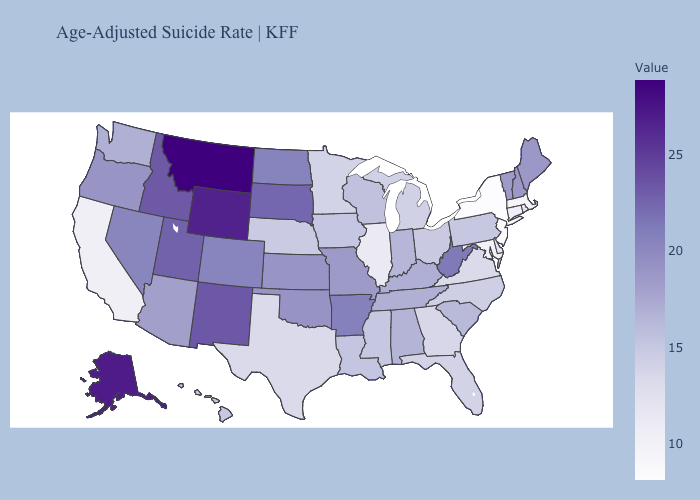Does Oregon have a higher value than New Jersey?
Short answer required. Yes. Which states have the highest value in the USA?
Answer briefly. Montana. Does Maine have the highest value in the Northeast?
Concise answer only. Yes. Does New York have the lowest value in the USA?
Write a very short answer. Yes. Does Kansas have the lowest value in the MidWest?
Answer briefly. No. Does Montana have the highest value in the USA?
Keep it brief. Yes. Among the states that border West Virginia , does Ohio have the highest value?
Quick response, please. No. Does South Dakota have a higher value than Indiana?
Answer briefly. Yes. Among the states that border Vermont , does New Hampshire have the highest value?
Quick response, please. Yes. Does Ohio have the highest value in the MidWest?
Keep it brief. No. 